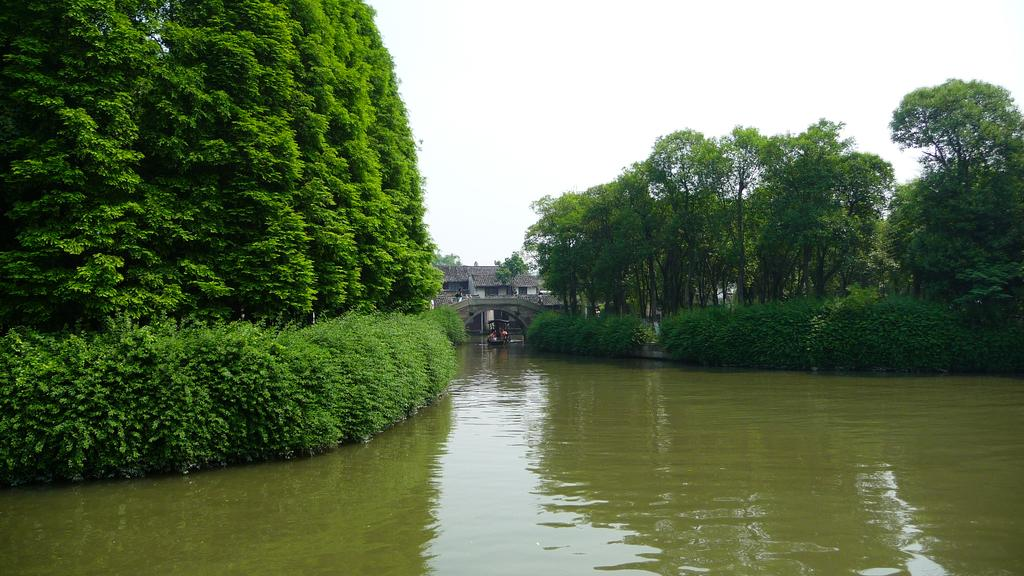What is the main subject of the image? The main subject of the image is a boat. Where is the boat located in the image? The boat is under a bridge in the image. What type of environment is depicted in the image? The image shows a large water body, plants, a group of trees, and a house with a roof. What is the condition of the sky in the image? The sky is visible in the image and appears cloudy. How many toes can be seen on the son in the image? There is no son or toes present in the image; it features a boat under a bridge with a large water body, plants, trees, and a house. 